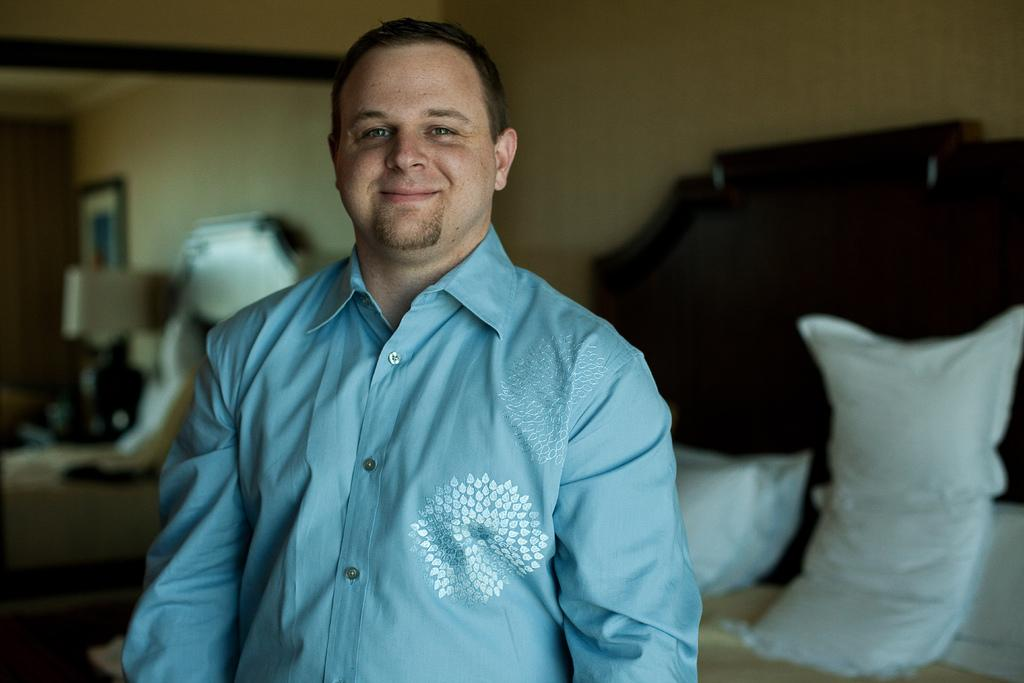What is the man in the image doing? The man is standing and smiling in the image. What can be seen on the bed in the image? There are pillows on the bed in the image. How would you describe the background of the image? The background of the image is blurry. What is visible in the background of the image? There is a wall visible in the background of the image. What word is the man writing on the wall in the image? There is no word or writing visible on the wall in the image. What type of pump is present in the image? There is no pump present in the image. 